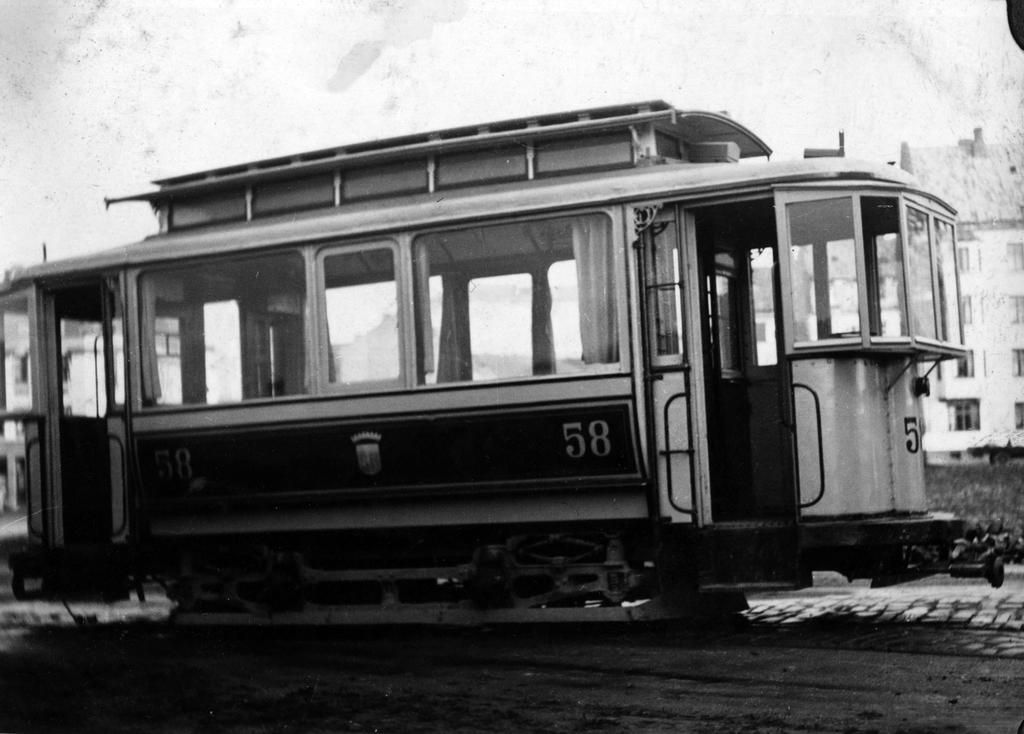What is the main subject in the middle of the image? There is a tram in the middle of the image. What can be seen on the right side of the image? There is a building on the right side of the image. What is visible in the background of the image? The sky is visible in the background of the image. How many beggars are visible in the image? There are no beggars present in the image. What type of hair can be seen on the tram in the image? There is no hair visible on the tram in the image, as it is an inanimate object. 